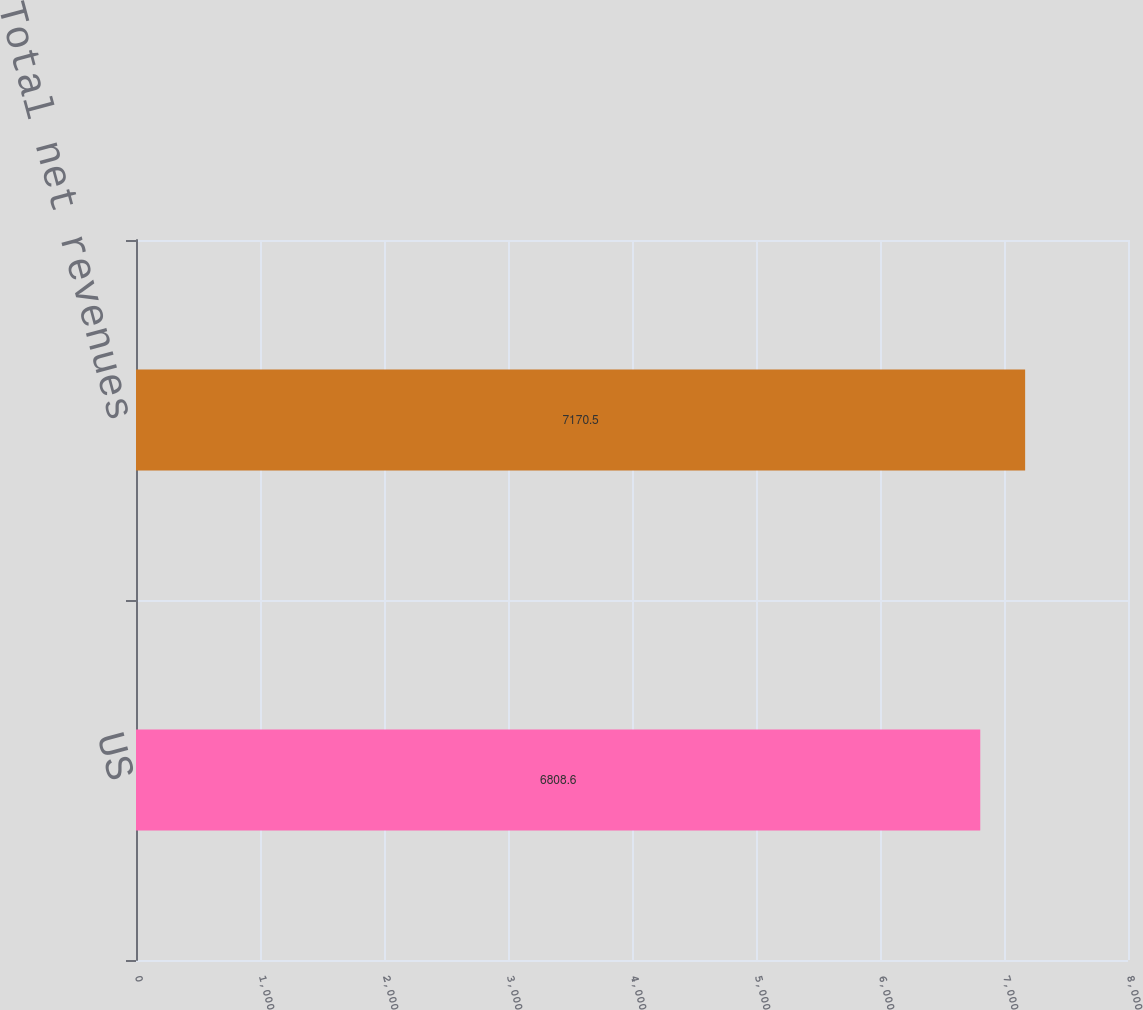<chart> <loc_0><loc_0><loc_500><loc_500><bar_chart><fcel>US<fcel>Total net revenues<nl><fcel>6808.6<fcel>7170.5<nl></chart> 